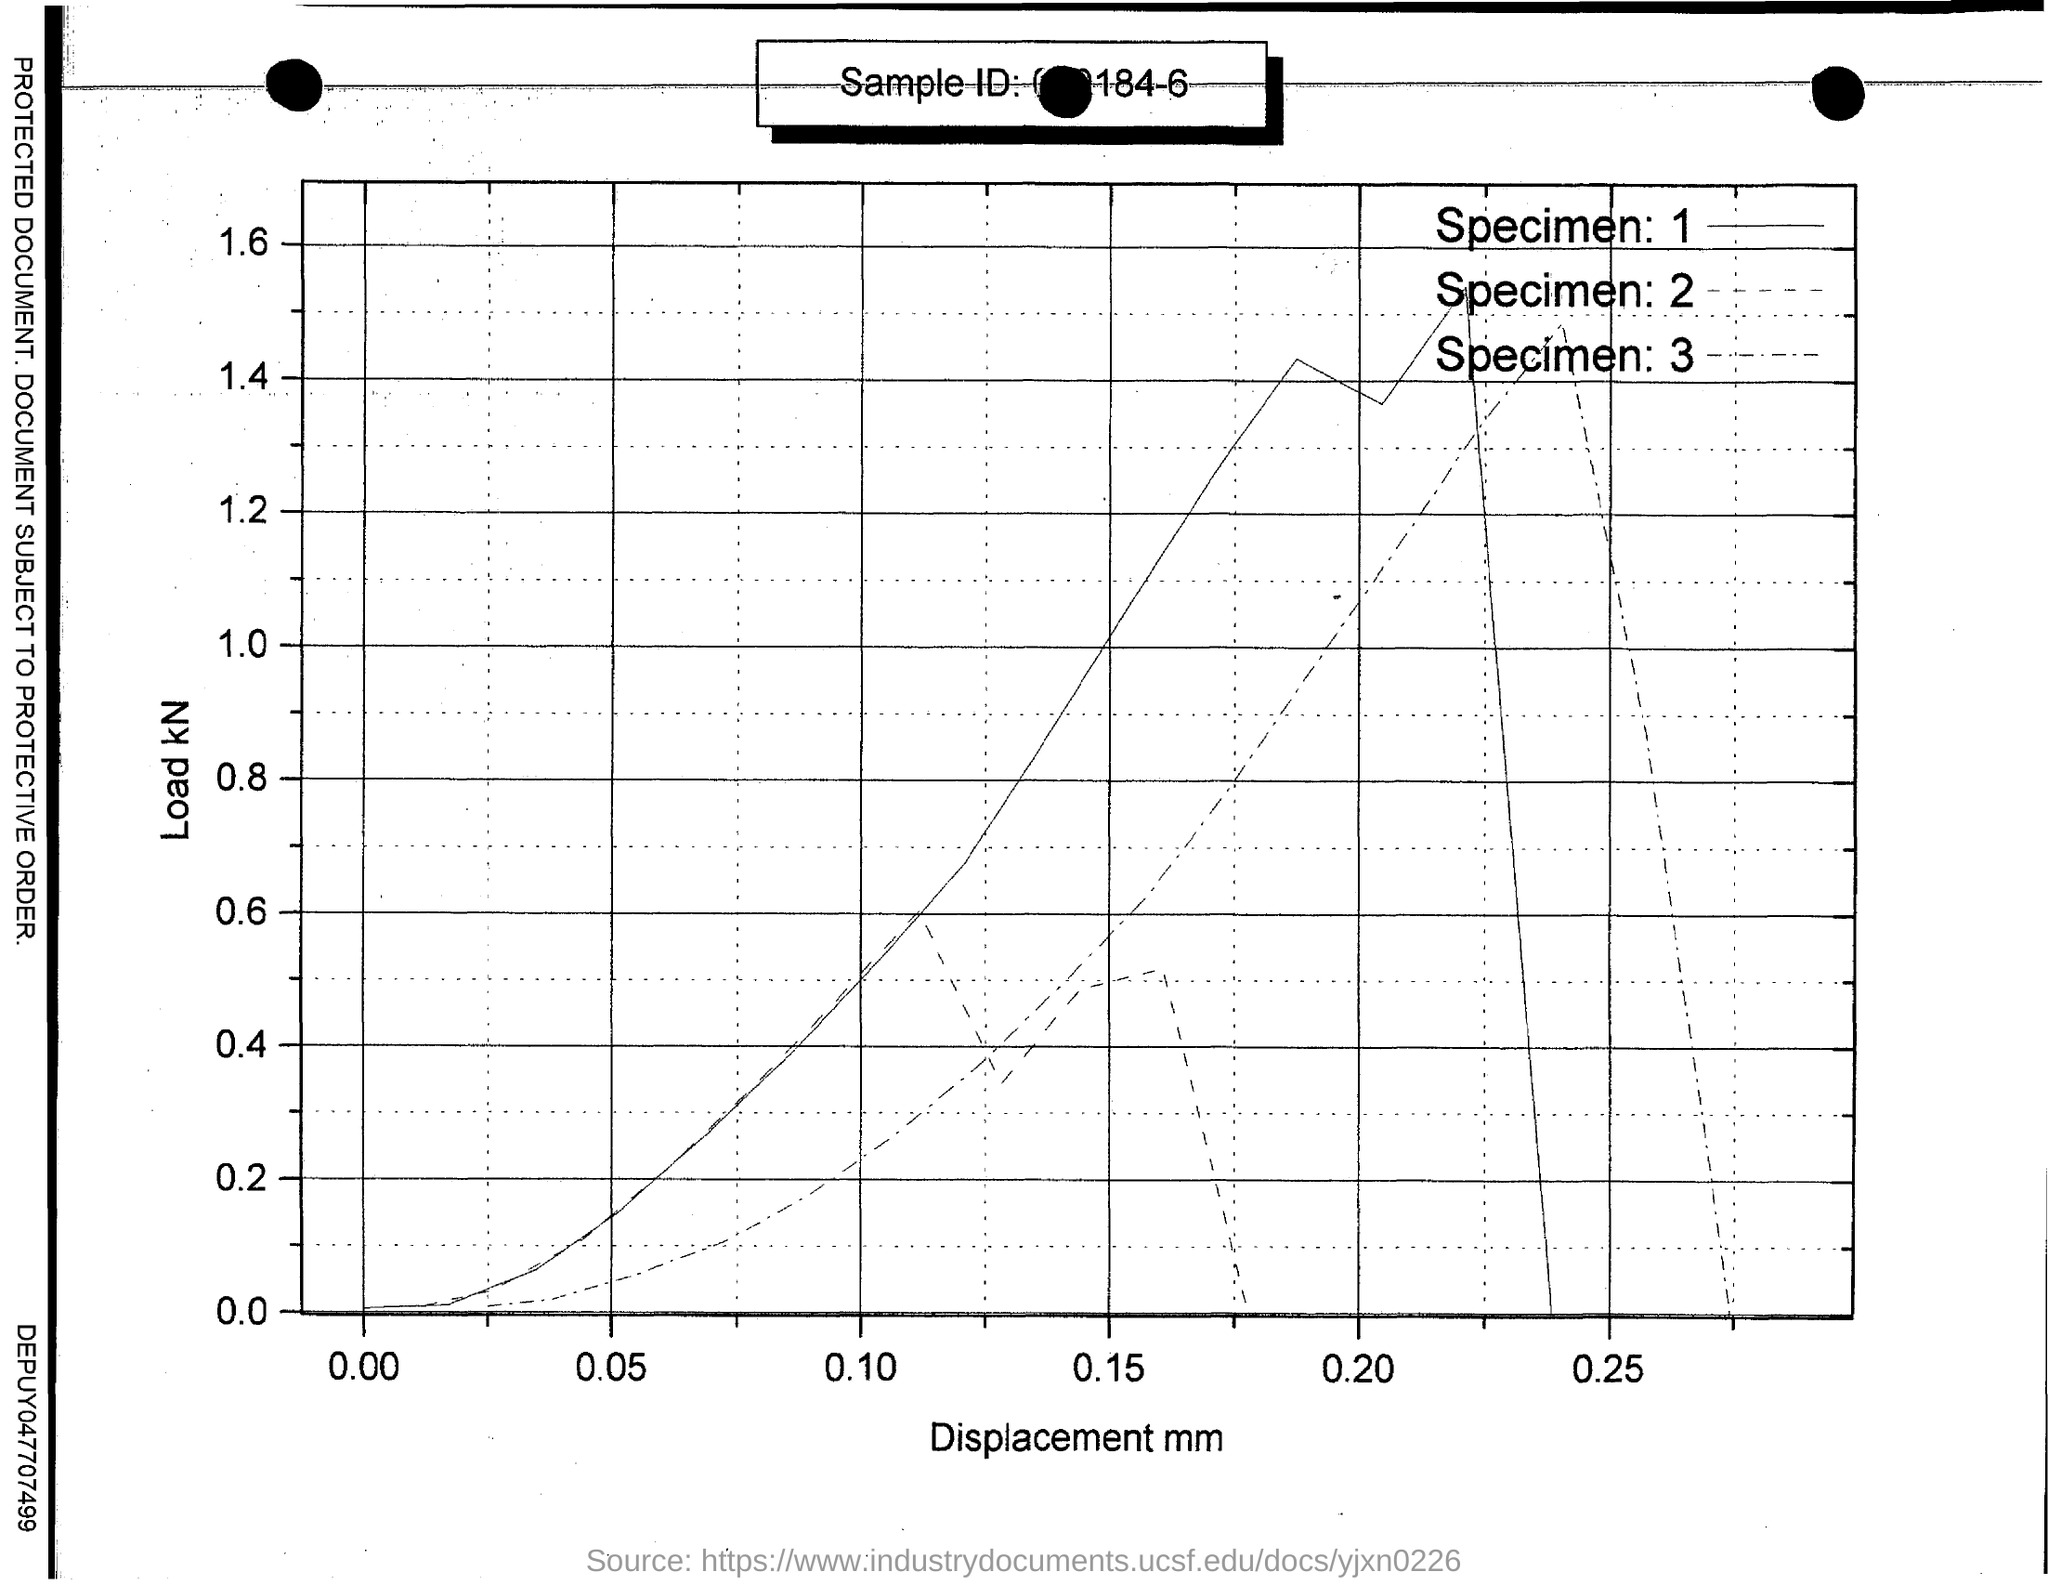What is plotted in the x-axis ?
Offer a very short reply. Displacement. What is plotted in the y-axis?
Give a very brief answer. Load kN. 